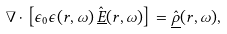<formula> <loc_0><loc_0><loc_500><loc_500>\nabla \cdot \left [ \epsilon _ { 0 } \epsilon ( { r } , \omega ) \, \hat { \underline { E } } ( { r } , \omega ) \right ] = \hat { \underline { \rho } } ( { r } , \omega ) ,</formula> 